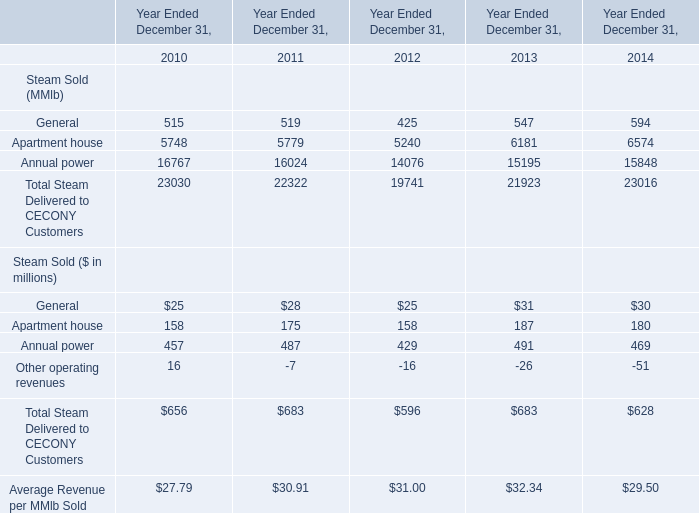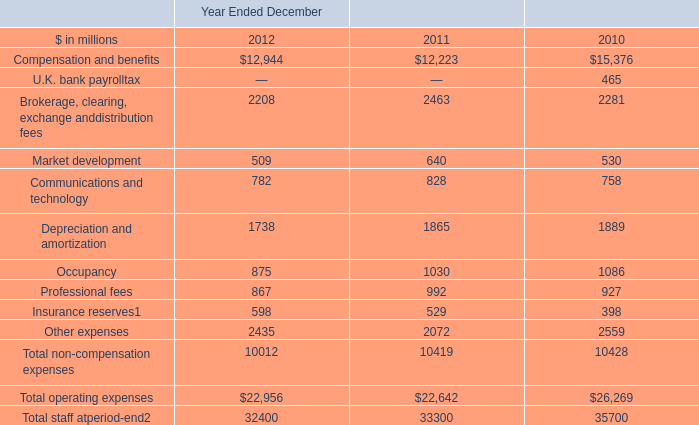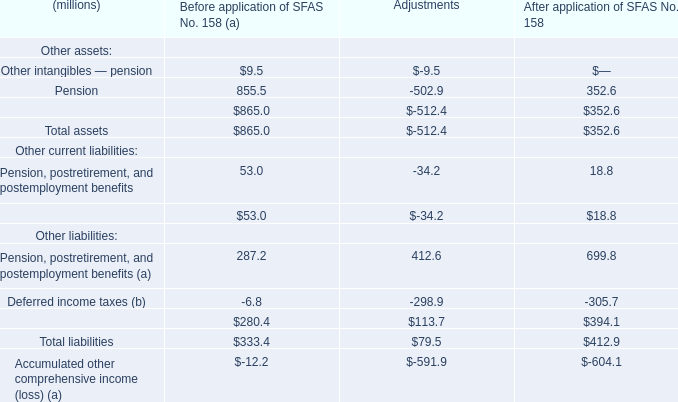What's the sum of Annual power of Year Ended December 31, 2012, and Depreciation and amortization of Year Ended December 2010 ? 
Computations: (14076.0 + 1889.0)
Answer: 15965.0. 